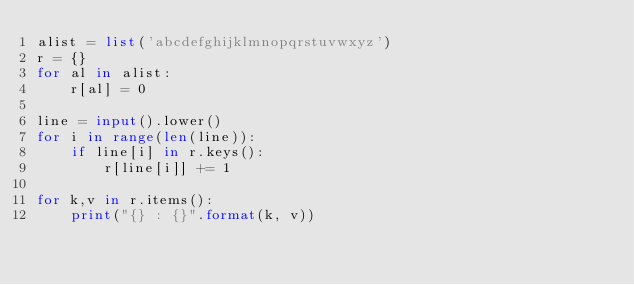<code> <loc_0><loc_0><loc_500><loc_500><_Python_>alist = list('abcdefghijklmnopqrstuvwxyz')
r = {}
for al in alist:
    r[al] = 0

line = input().lower()
for i in range(len(line)):
    if line[i] in r.keys():
        r[line[i]] += 1

for k,v in r.items():
    print("{} : {}".format(k, v))
</code> 